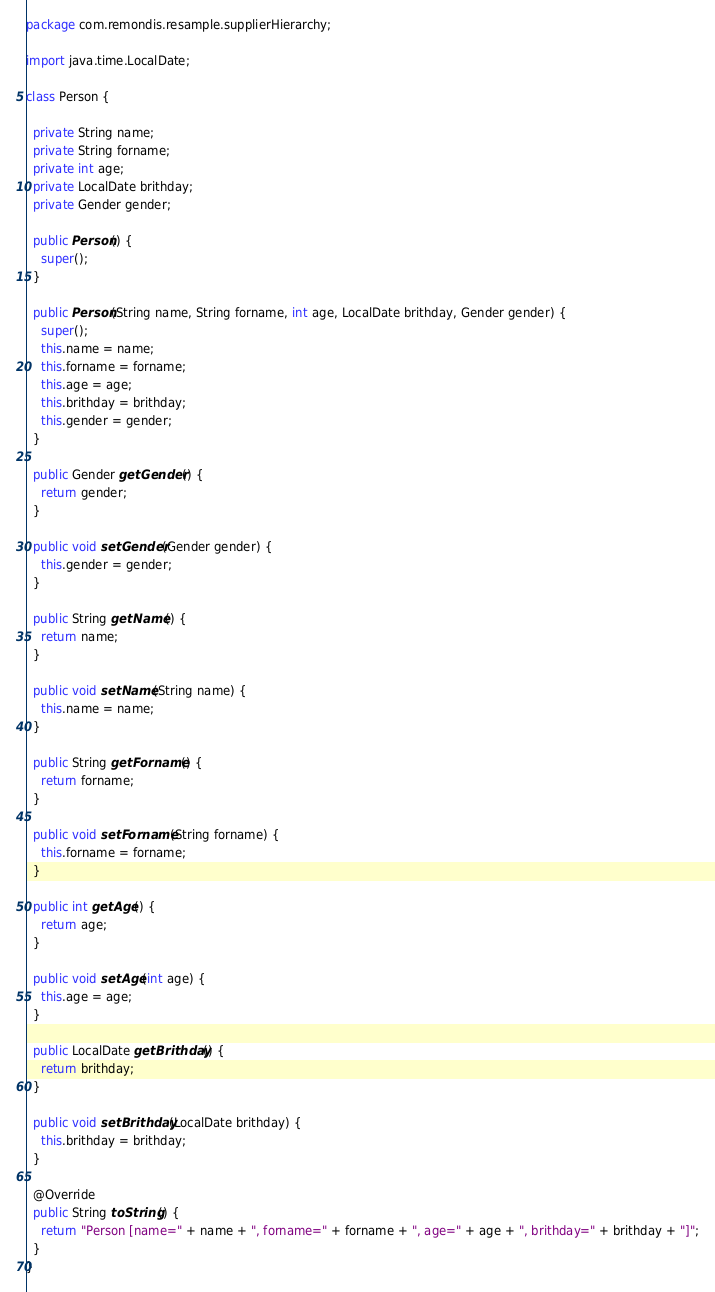<code> <loc_0><loc_0><loc_500><loc_500><_Java_>package com.remondis.resample.supplierHierarchy;

import java.time.LocalDate;

class Person {

  private String name;
  private String forname;
  private int age;
  private LocalDate brithday;
  private Gender gender;

  public Person() {
    super();
  }

  public Person(String name, String forname, int age, LocalDate brithday, Gender gender) {
    super();
    this.name = name;
    this.forname = forname;
    this.age = age;
    this.brithday = brithday;
    this.gender = gender;
  }

  public Gender getGender() {
    return gender;
  }

  public void setGender(Gender gender) {
    this.gender = gender;
  }

  public String getName() {
    return name;
  }

  public void setName(String name) {
    this.name = name;
  }

  public String getForname() {
    return forname;
  }

  public void setForname(String forname) {
    this.forname = forname;
  }

  public int getAge() {
    return age;
  }

  public void setAge(int age) {
    this.age = age;
  }

  public LocalDate getBrithday() {
    return brithday;
  }

  public void setBrithday(LocalDate brithday) {
    this.brithday = brithday;
  }

  @Override
  public String toString() {
    return "Person [name=" + name + ", forname=" + forname + ", age=" + age + ", brithday=" + brithday + "]";
  }
}
</code> 